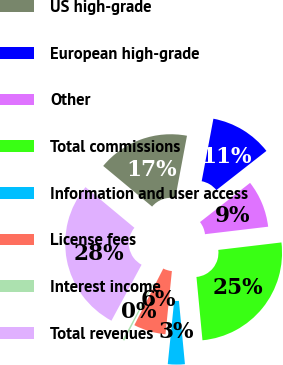Convert chart. <chart><loc_0><loc_0><loc_500><loc_500><pie_chart><fcel>US high-grade<fcel>European high-grade<fcel>Other<fcel>Total commissions<fcel>Information and user access<fcel>License fees<fcel>Interest income<fcel>Total revenues<nl><fcel>16.91%<fcel>11.48%<fcel>8.69%<fcel>25.37%<fcel>3.12%<fcel>5.91%<fcel>0.34%<fcel>28.18%<nl></chart> 